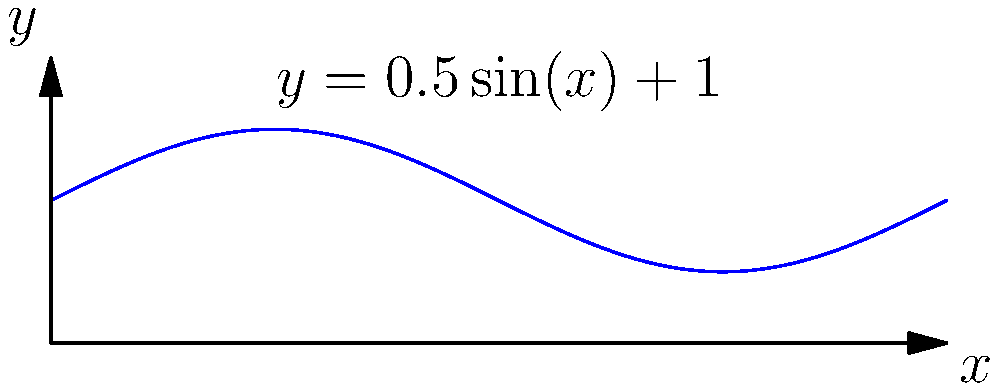Your rock-star grandpa wants to create a unique guitar-shaped solid. He describes the body of the guitar using the curve $y = 0.5\sin(x) + 1$ from $x = 0$ to $x = 2\pi$, rotated around the x-axis. What's the volume of this groovy guitar-shaped solid? Let's rock through this step-by-step:

1) The volume of a solid formed by rotating a curve $y = f(x)$ around the x-axis from $a$ to $b$ is given by the formula:

   $$V = \pi \int_{a}^{b} [f(x)]^2 dx$$

2) In our case, $f(x) = 0.5\sin(x) + 1$, $a = 0$, and $b = 2\pi$. Let's plug these into our formula:

   $$V = \pi \int_{0}^{2\pi} [0.5\sin(x) + 1]^2 dx$$

3) Let's expand the squared term:

   $$V = \pi \int_{0}^{2\pi} [0.25\sin^2(x) + \sin(x) + 1] dx$$

4) Now we can split this into three integrals:

   $$V = \pi [\int_{0}^{2\pi} 0.25\sin^2(x) dx + \int_{0}^{2\pi} \sin(x) dx + \int_{0}^{2\pi} 1 dx]$$

5) Let's solve each integral:
   - $\int_{0}^{2\pi} \sin^2(x) dx = \pi$
   - $\int_{0}^{2\pi} \sin(x) dx = 0$
   - $\int_{0}^{2\pi} 1 dx = 2\pi$

6) Plugging these back in:

   $$V = \pi [0.25\pi + 0 + 2\pi] = \pi [2.25\pi]$$

7) Simplifying:

   $$V = 2.25\pi^2$$

That's one rockin' guitar shape!
Answer: $2.25\pi^2$ cubic units 